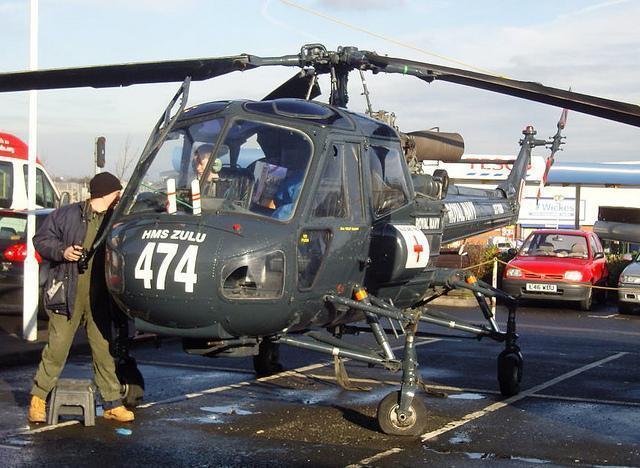What kind of chopper is this?
From the following set of four choices, select the accurate answer to respond to the question.
Options: Cargo, attack, medical, law enforcement. Medical. 